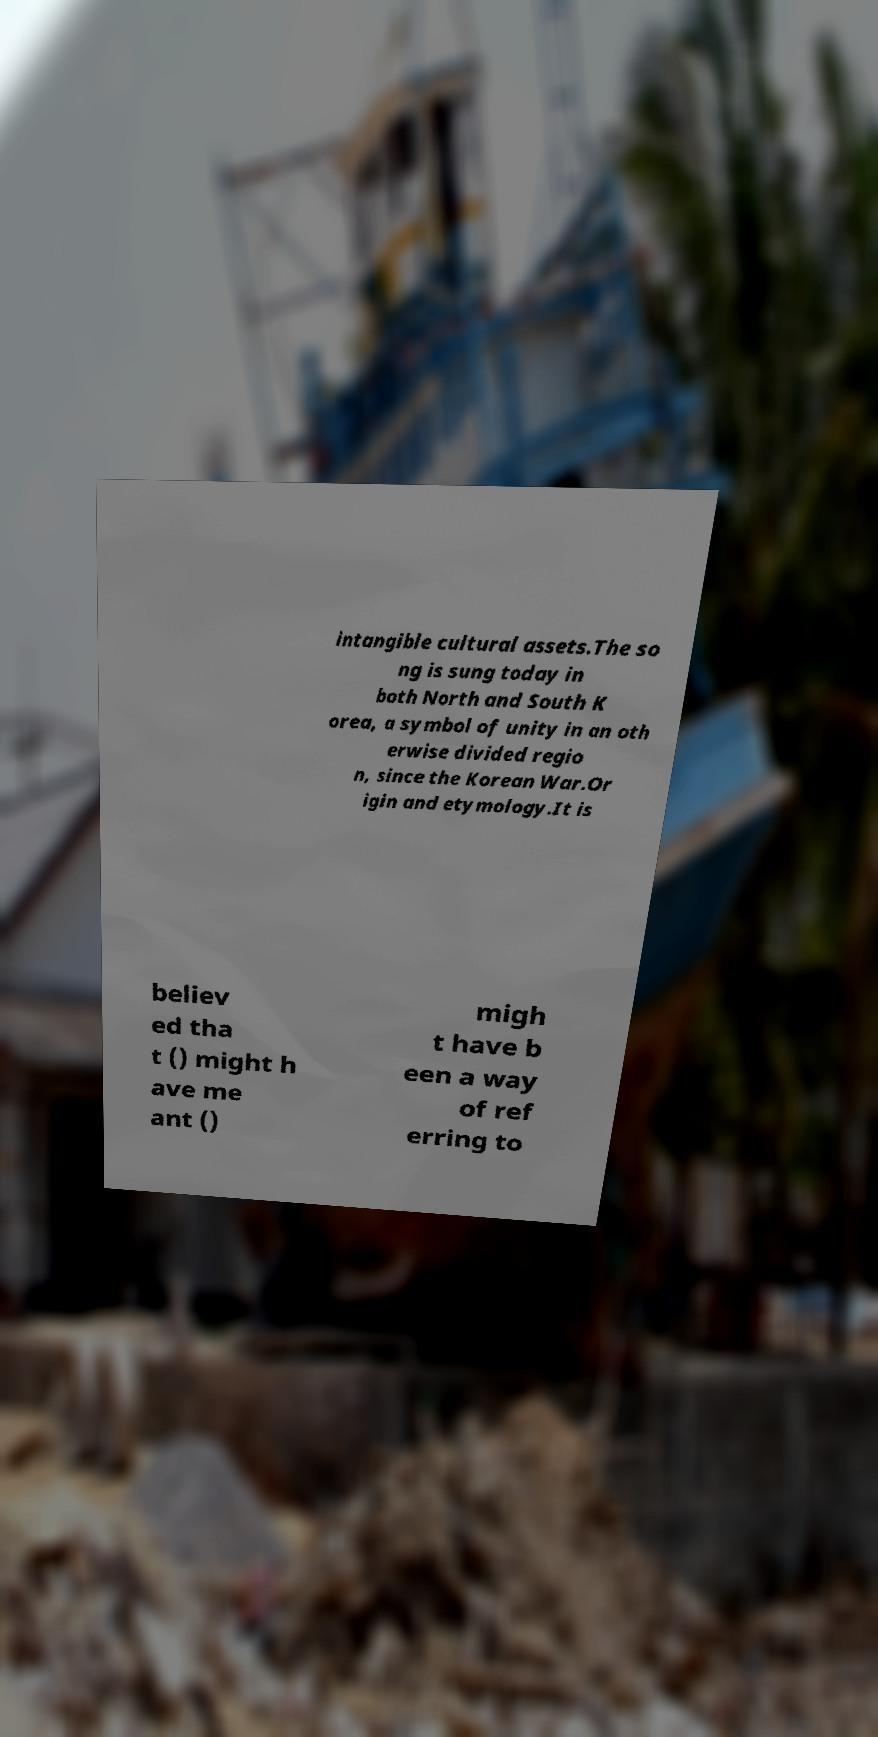Could you assist in decoding the text presented in this image and type it out clearly? intangible cultural assets.The so ng is sung today in both North and South K orea, a symbol of unity in an oth erwise divided regio n, since the Korean War.Or igin and etymology.It is believ ed tha t () might h ave me ant () migh t have b een a way of ref erring to 